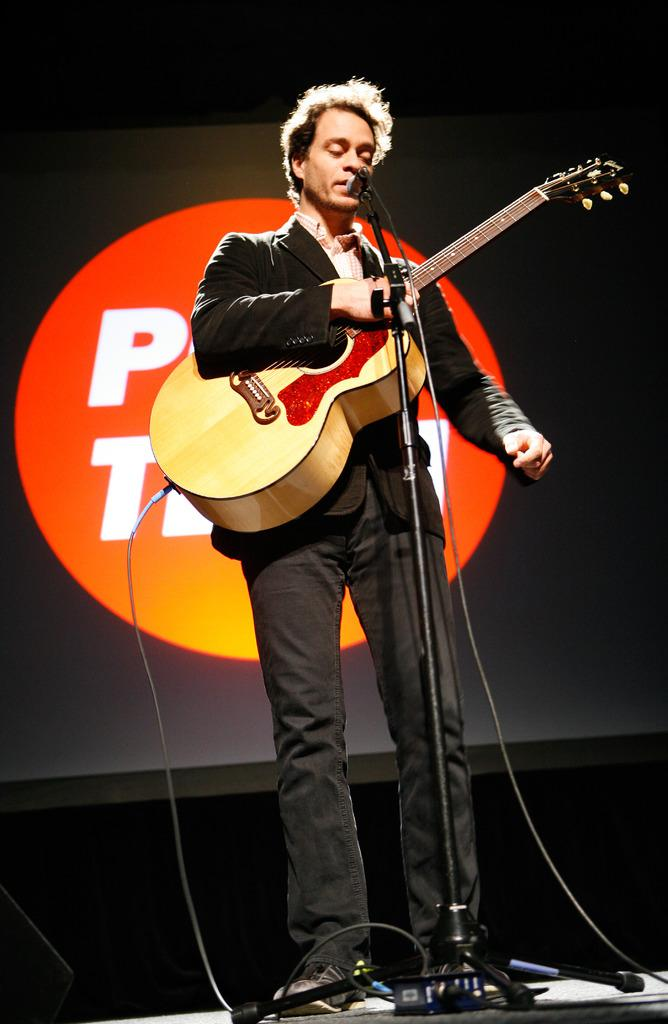What is the man in the image doing? The man is singing and playing a guitar. What is the man holding in the image? The man is holding a microphone. What can be seen in the background of the image? There is a screen in the background of the image. How many bushes are visible in the image? There are no bushes present in the image. What type of porter is assisting the man in the image? There is no porter present in the image. 